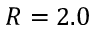<formula> <loc_0><loc_0><loc_500><loc_500>R = 2 . 0</formula> 